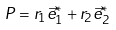Convert formula to latex. <formula><loc_0><loc_0><loc_500><loc_500>P = r _ { 1 } \vec { e } _ { 1 } ^ { * } + r _ { 2 } \vec { e } _ { 2 } ^ { * }</formula> 